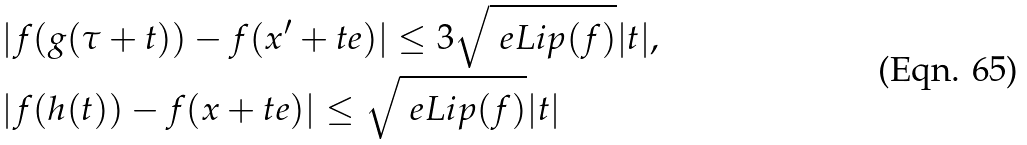<formula> <loc_0><loc_0><loc_500><loc_500>& | f ( g ( \tau + t ) ) - f ( x ^ { \prime } + t e ) | \leq 3 \sqrt { \ e L i p ( f ) } | t | , \\ & | f ( h ( t ) ) - f ( x + t e ) | \leq \sqrt { { \ e } { L i p ( f ) } } | t |</formula> 